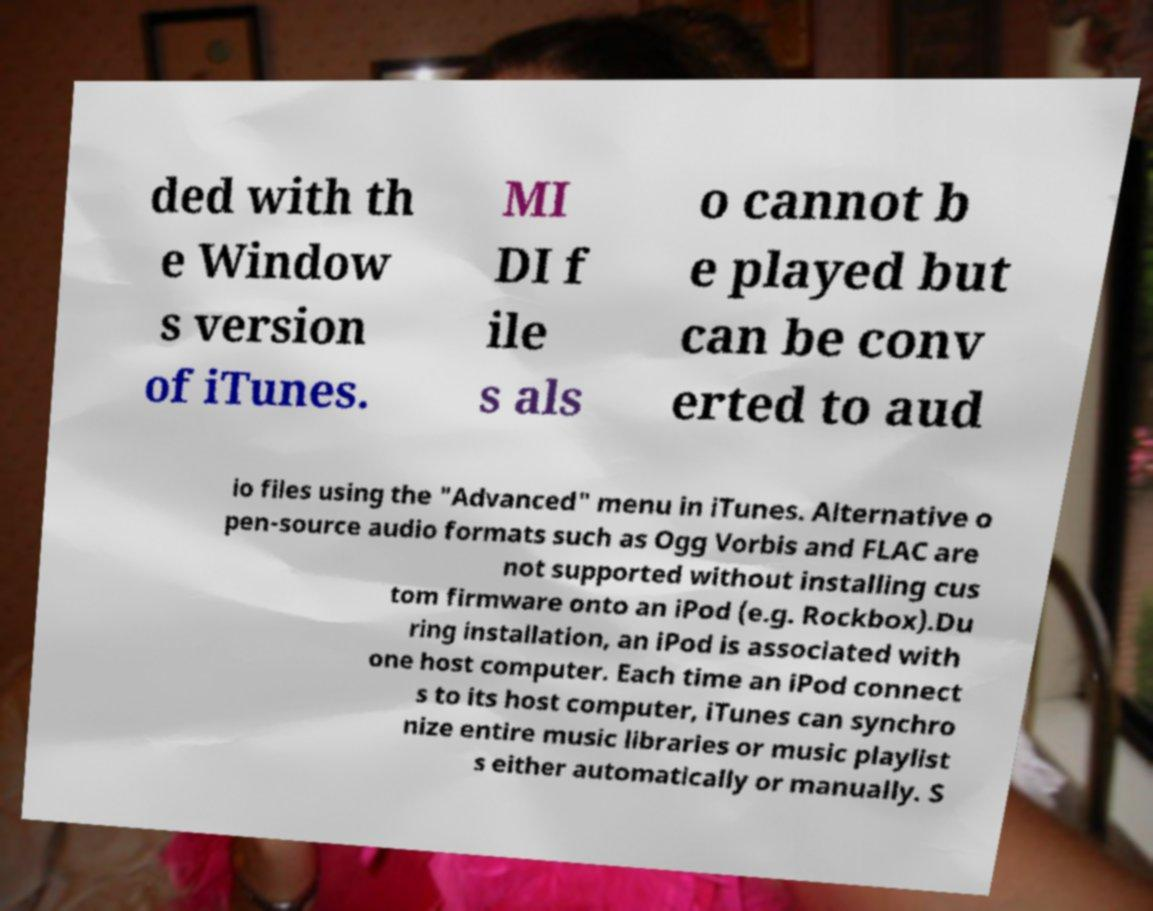What messages or text are displayed in this image? I need them in a readable, typed format. ded with th e Window s version of iTunes. MI DI f ile s als o cannot b e played but can be conv erted to aud io files using the "Advanced" menu in iTunes. Alternative o pen-source audio formats such as Ogg Vorbis and FLAC are not supported without installing cus tom firmware onto an iPod (e.g. Rockbox).Du ring installation, an iPod is associated with one host computer. Each time an iPod connect s to its host computer, iTunes can synchro nize entire music libraries or music playlist s either automatically or manually. S 